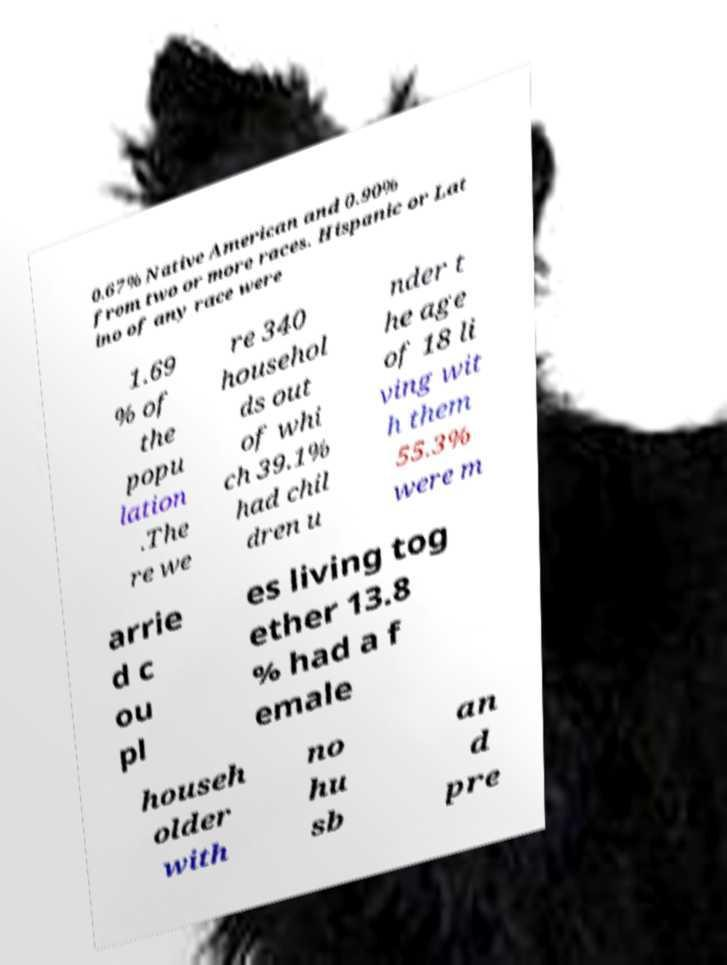Could you assist in decoding the text presented in this image and type it out clearly? 0.67% Native American and 0.90% from two or more races. Hispanic or Lat ino of any race were 1.69 % of the popu lation .The re we re 340 househol ds out of whi ch 39.1% had chil dren u nder t he age of 18 li ving wit h them 55.3% were m arrie d c ou pl es living tog ether 13.8 % had a f emale househ older with no hu sb an d pre 